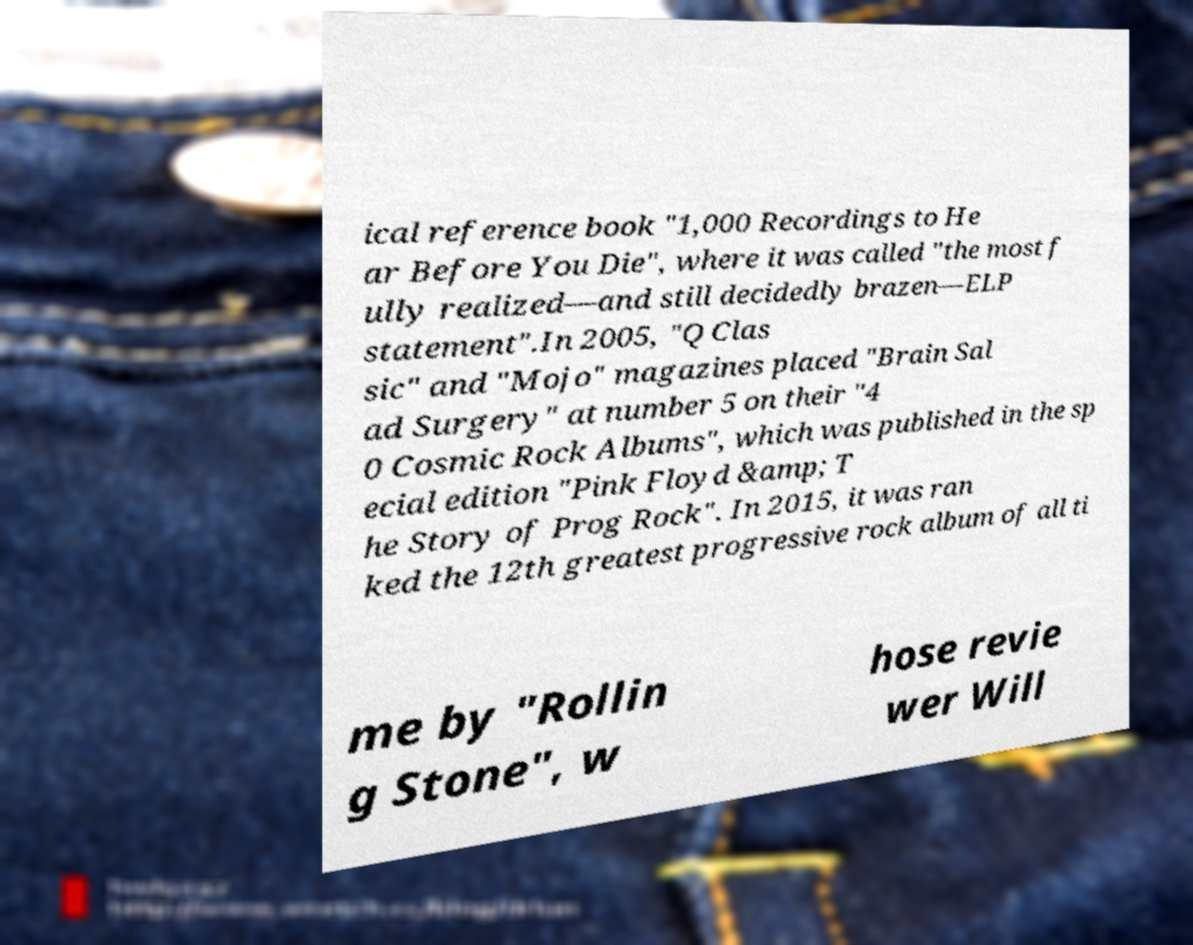Can you read and provide the text displayed in the image?This photo seems to have some interesting text. Can you extract and type it out for me? ical reference book "1,000 Recordings to He ar Before You Die", where it was called "the most f ully realized—and still decidedly brazen—ELP statement".In 2005, "Q Clas sic" and "Mojo" magazines placed "Brain Sal ad Surgery" at number 5 on their "4 0 Cosmic Rock Albums", which was published in the sp ecial edition "Pink Floyd &amp; T he Story of Prog Rock". In 2015, it was ran ked the 12th greatest progressive rock album of all ti me by "Rollin g Stone", w hose revie wer Will 